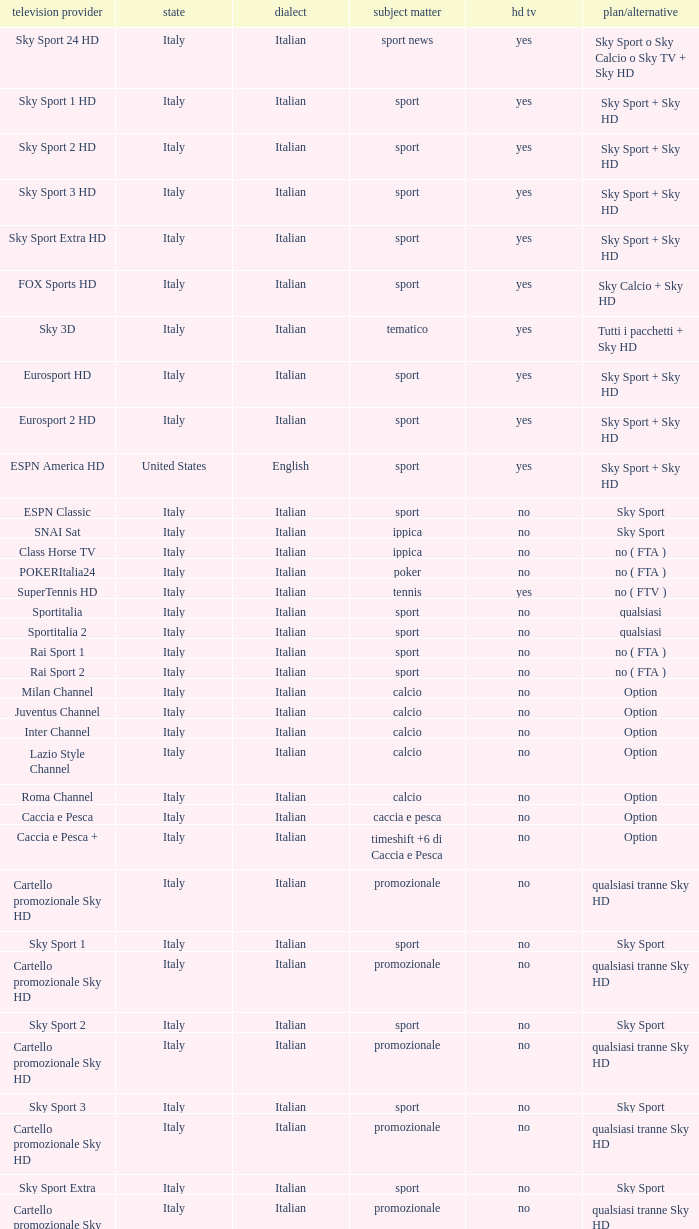What is Television Service, when Content is Calcio, and when Package/Option is Option? Milan Channel, Juventus Channel, Inter Channel, Lazio Style Channel, Roma Channel. 